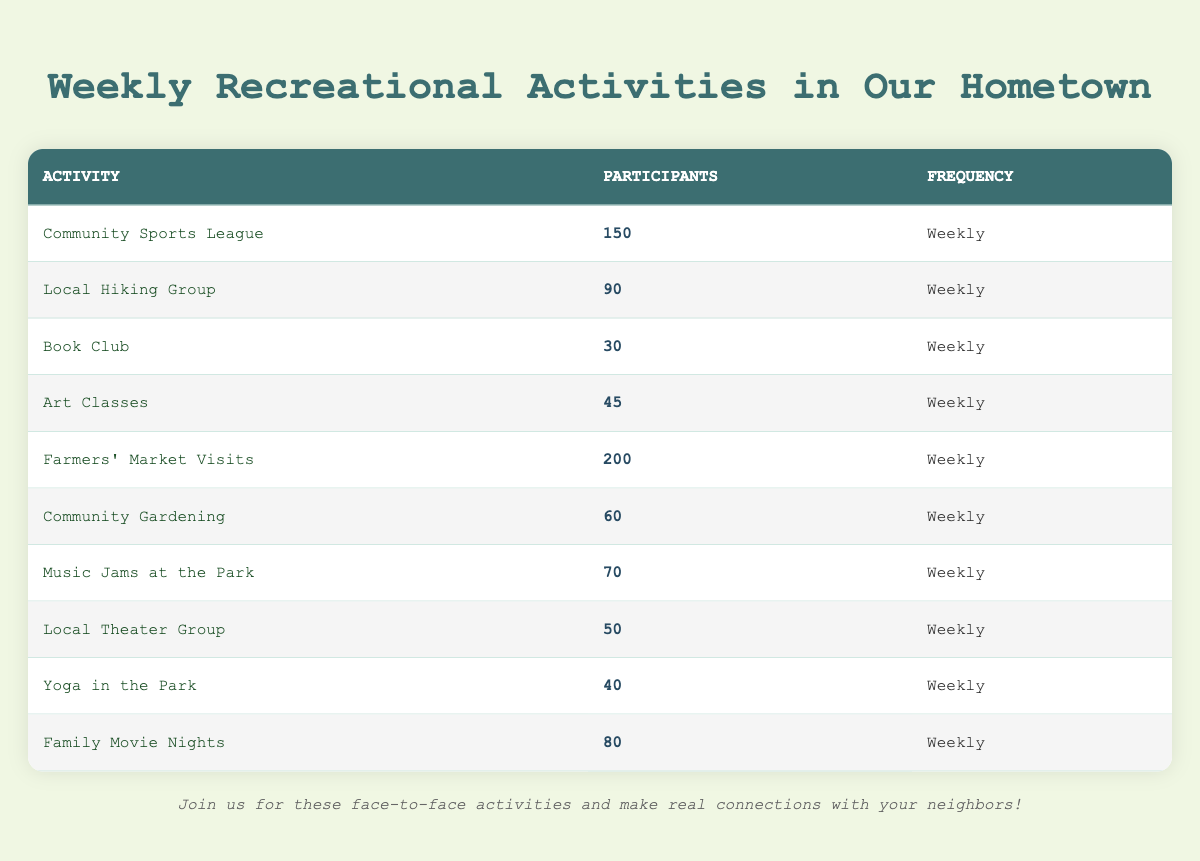What is the total number of participants in the Farmers' Market Visits activity? The number of participants listed for Farmers' Market Visits is 200, which is explicitly stated in the table under the "Participants" column for that activity.
Answer: 200 Which activity has the least number of participants? The activity with the least number of participants listed in the table is the Book Club, with only 30 participants. This is the smallest value in the "Participants" column.
Answer: Book Club What is the average number of participants across all activities? To find the average, we first sum the participants: 150 + 90 + 30 + 45 + 200 + 60 + 70 + 50 + 40 + 80 = 815. There are 10 activities, so we divide the total by 10: 815 / 10 = 81.5.
Answer: 81.5 Is there an activity with more than 100 participants? Yes, the Farmers' Market Visits is the only activity that has more than 100 participants, as it has 200 participants. This is confirmed by comparing each participant count in the table.
Answer: Yes What is the difference in participants between the Community Sports League and the Local Theater Group? The Community Sports League has 150 participants, while the Local Theater Group has 50 participants. To find the difference, we subtract the number of participants in the Local Theater Group from the Community Sports League: 150 - 50 = 100.
Answer: 100 What percentage of participants belong to the Local Hiking Group compared to the total participants in all activities? The total number of participants is 815. The Local Hiking Group has 90 participants. To find the percentage, we calculate (90 / 815) * 100, which equals approximately 11.04%.
Answer: 11.04% How many activities have fewer than 60 participants? We review the participants' counts and see that the activities with fewer than 60 participants are the Book Club (30) and Art Classes (45). Therefore, there are 2 activities with fewer than 60 participants.
Answer: 2 Are there more participants in the Family Movie Nights than in the Yoga in the Park? Yes, Family Movie Nights has 80 participants while Yoga in the Park has 40 participants. A direct comparison between these two values confirms that Family Movie Nights has more participants.
Answer: Yes If we only consider activities involving sports or physical activities (like Community Sports League, Local Hiking Group, and Yoga in the Park), what is their combined total? The participants for the selected activities are: Community Sports League (150), Local Hiking Group (90), and Yoga in the Park (40). Adding these gives: 150 + 90 + 40 = 280 participants total.
Answer: 280 